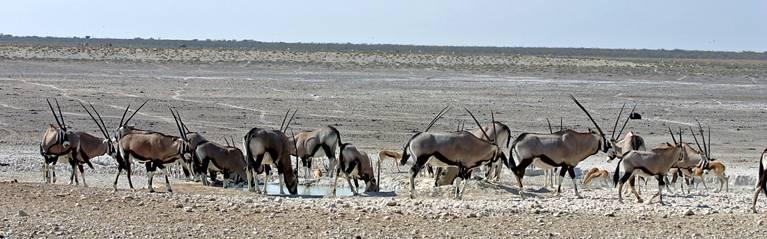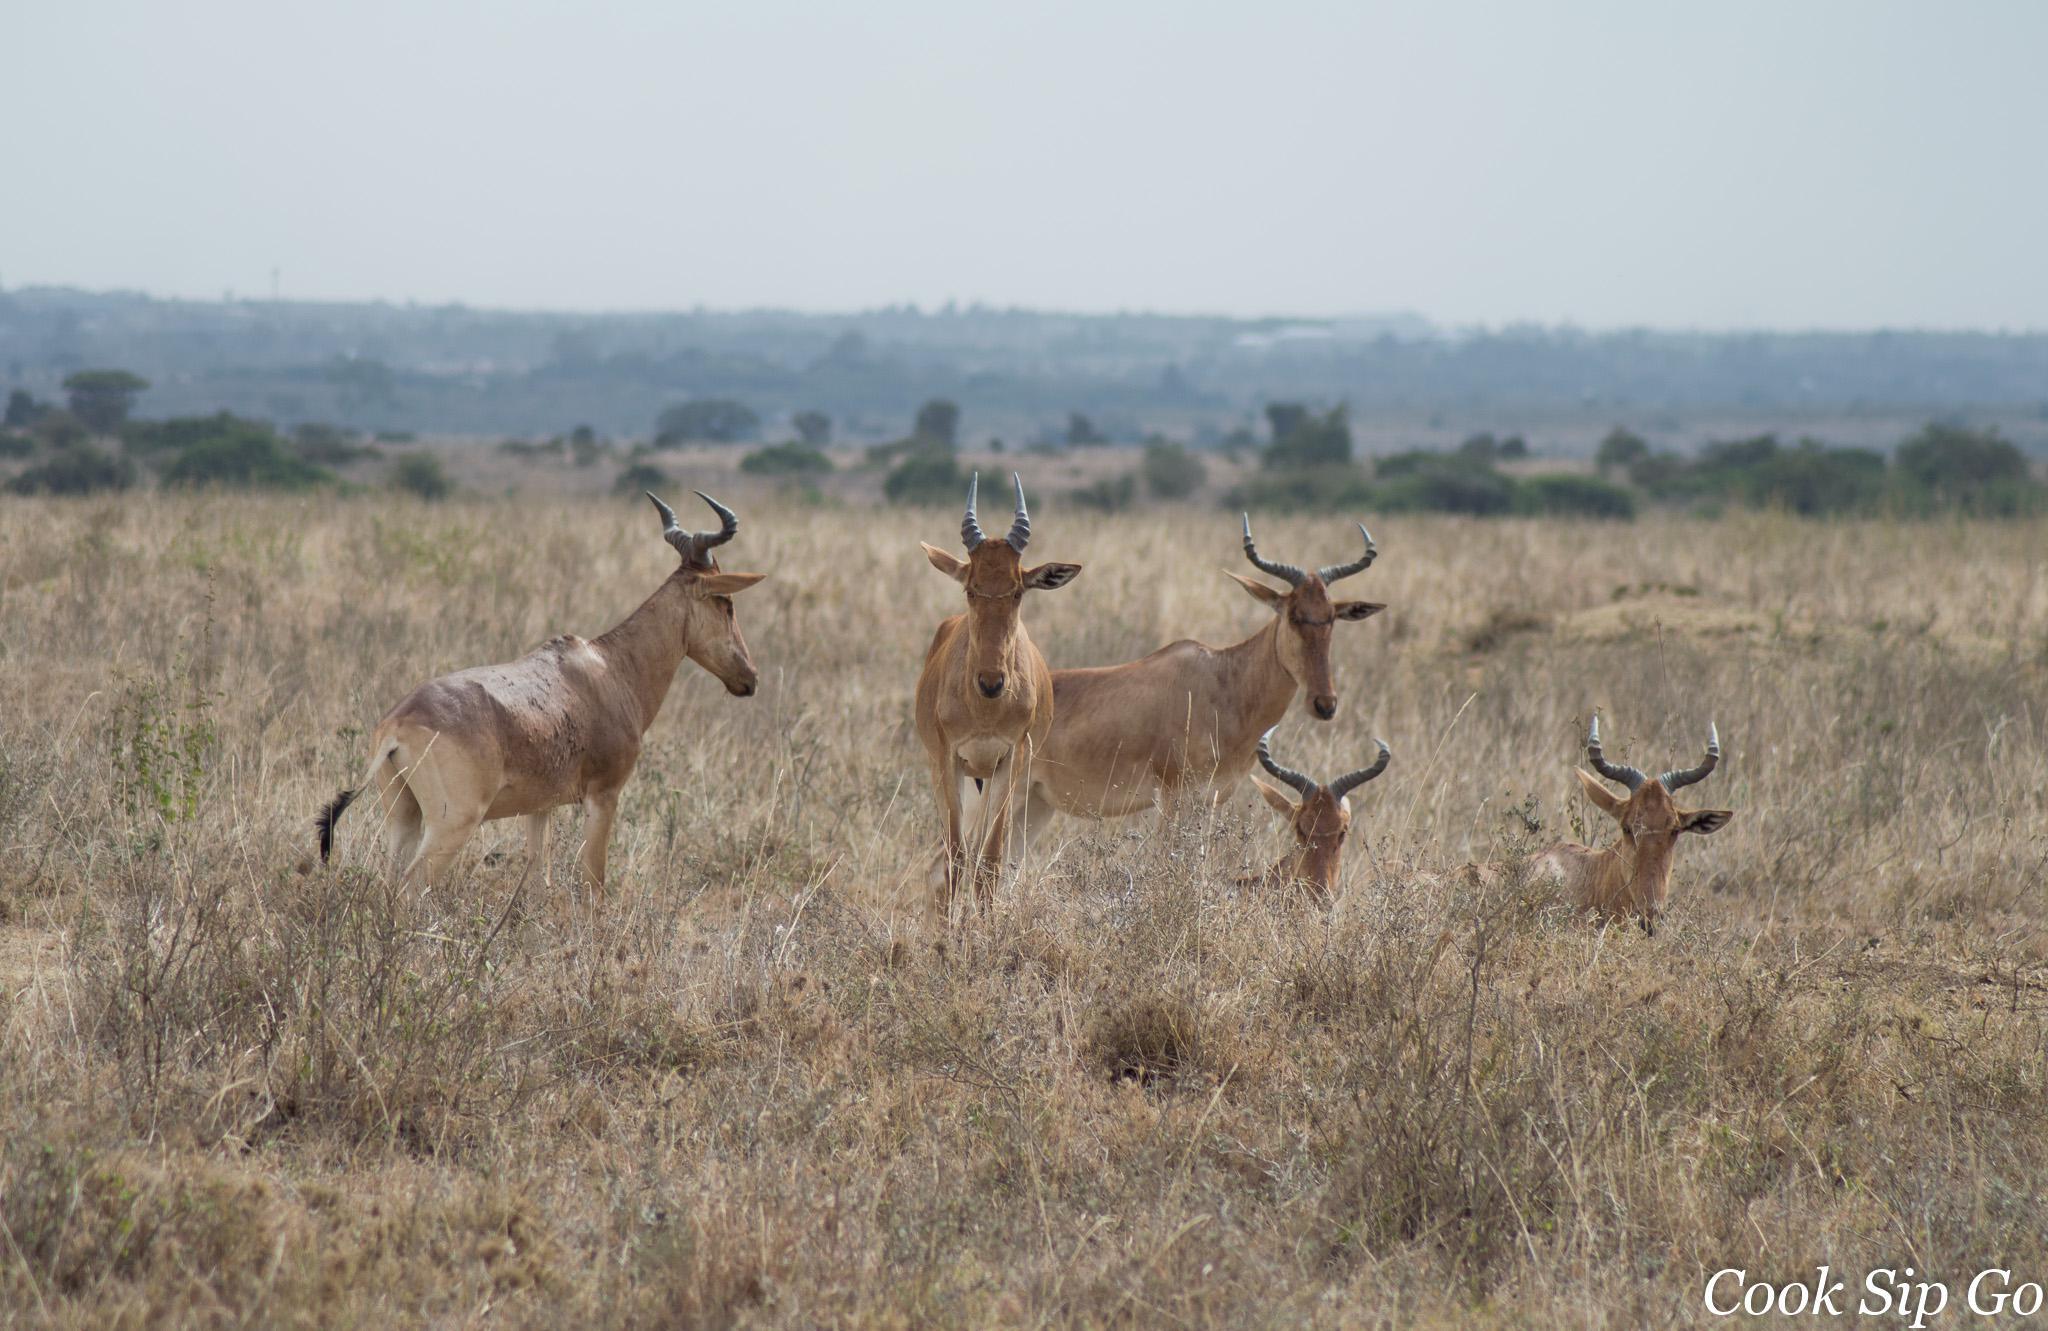The first image is the image on the left, the second image is the image on the right. Given the left and right images, does the statement "Zebra are present with horned animals in one image." hold true? Answer yes or no. No. 